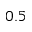<formula> <loc_0><loc_0><loc_500><loc_500>0 . 5</formula> 